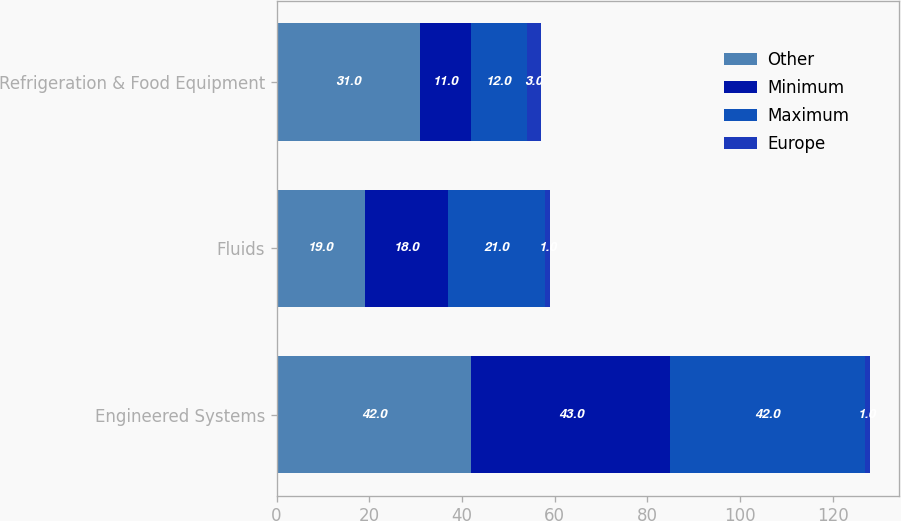<chart> <loc_0><loc_0><loc_500><loc_500><stacked_bar_chart><ecel><fcel>Engineered Systems<fcel>Fluids<fcel>Refrigeration & Food Equipment<nl><fcel>Other<fcel>42<fcel>19<fcel>31<nl><fcel>Minimum<fcel>43<fcel>18<fcel>11<nl><fcel>Maximum<fcel>42<fcel>21<fcel>12<nl><fcel>Europe<fcel>1<fcel>1<fcel>3<nl></chart> 